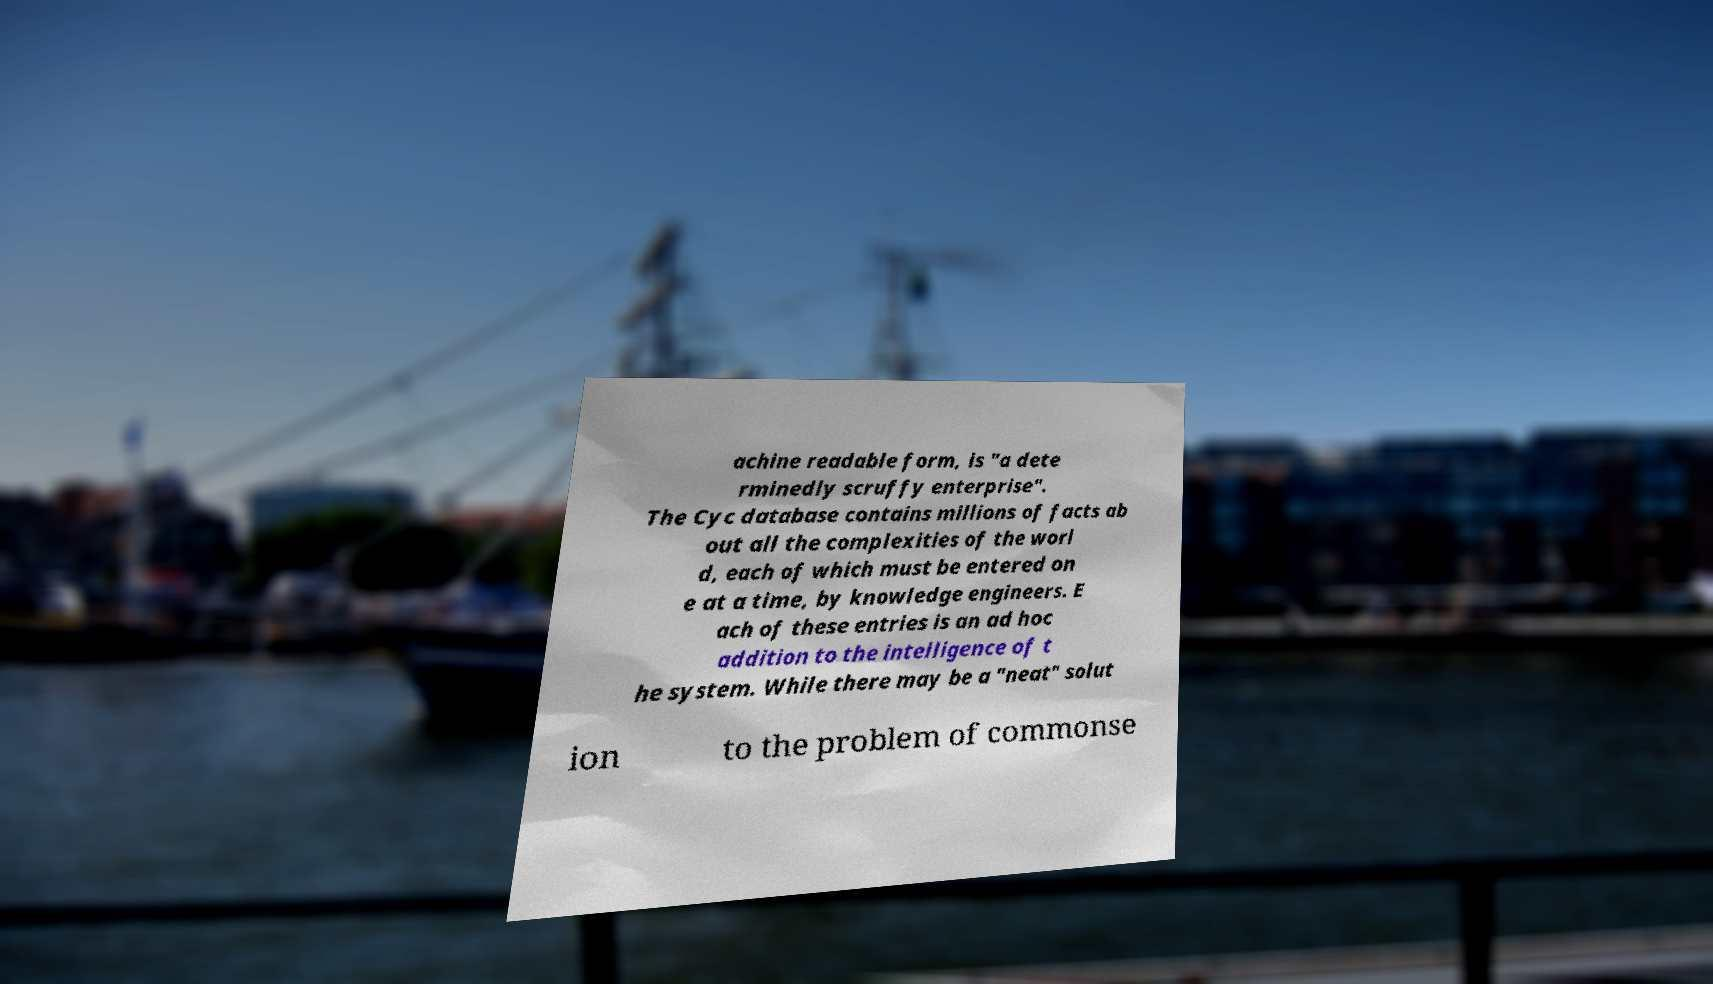Please read and relay the text visible in this image. What does it say? achine readable form, is "a dete rminedly scruffy enterprise". The Cyc database contains millions of facts ab out all the complexities of the worl d, each of which must be entered on e at a time, by knowledge engineers. E ach of these entries is an ad hoc addition to the intelligence of t he system. While there may be a "neat" solut ion to the problem of commonse 